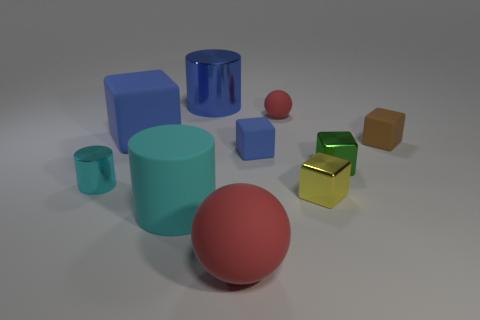Subtract all metal blocks. How many blocks are left? 3 Subtract 1 blocks. How many blocks are left? 4 Subtract all blue cylinders. How many cylinders are left? 2 Add 8 small brown objects. How many small brown objects exist? 9 Subtract 1 blue blocks. How many objects are left? 9 Subtract all cylinders. How many objects are left? 7 Subtract all yellow spheres. Subtract all gray cylinders. How many spheres are left? 2 Subtract all cyan blocks. How many purple balls are left? 0 Subtract all tiny blue matte objects. Subtract all tiny purple blocks. How many objects are left? 9 Add 9 cyan rubber objects. How many cyan rubber objects are left? 10 